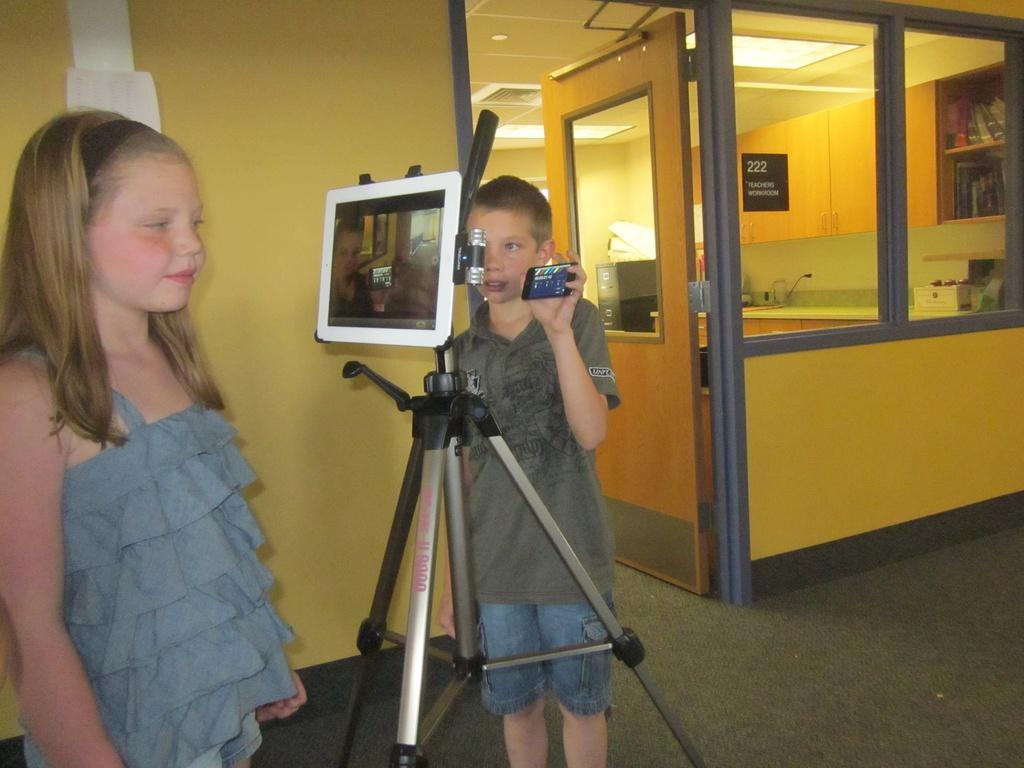Who is standing on the left side of the image? There is a girl standing on the left side of the image. What is located in the middle of the image? There is a stand in the middle of the image. Who is standing on the right side of the image? There is a boy standing on the right side of the image. What type of clothing is the boy wearing on his upper body? The boy is wearing a t-shirt. What type of clothing is the boy wearing on his lower body? The boy is wearing shorts. What type of oil can be seen dripping from the snail in the image? There is no snail or oil present in the image. How does the roll affect the position of the girl on the left side of the image? There is no roll present in the image, so it cannot affect the position of the girl. 